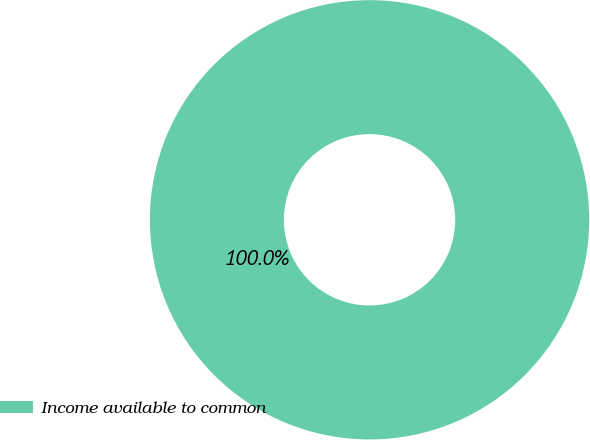<chart> <loc_0><loc_0><loc_500><loc_500><pie_chart><fcel>Income available to common<nl><fcel>100.0%<nl></chart> 